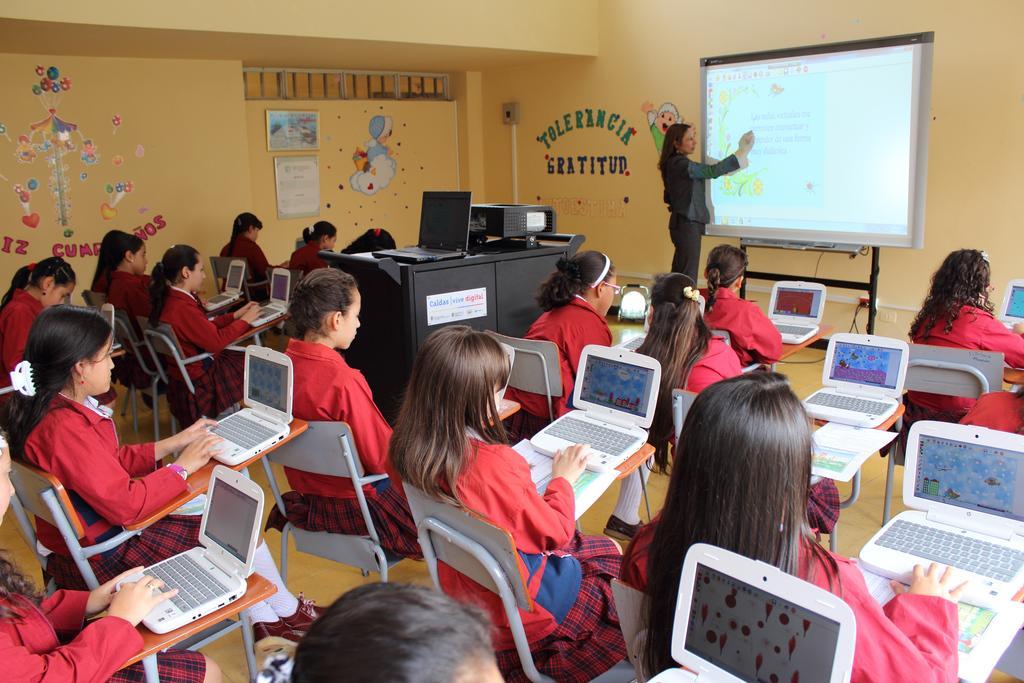Could you give a brief overview of what you see in this image? In the background we can see the wall, there are boards and stickers on the wall. On the right side of the picture we can see a woman standing near to a screen and explaining. In this picture we can see students sitting on the chairs wearing uniform and we can see laptops. We can see a black table and on it there is a laptop and a device. 